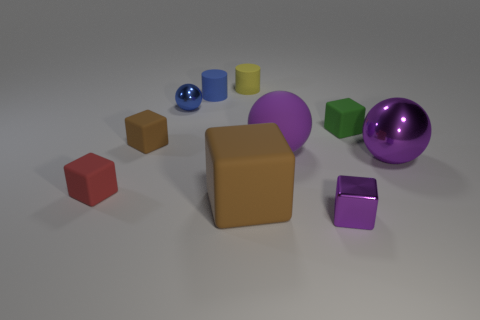There is a brown matte cube on the left side of the big rubber cube; what size is it?
Your answer should be very brief. Small. What number of yellow things are either tiny cylinders or small things?
Keep it short and to the point. 1. There is a small purple object that is the same shape as the small red rubber thing; what is it made of?
Your answer should be compact. Metal. Are there the same number of small green cubes in front of the tiny purple object and large red rubber cylinders?
Your answer should be very brief. Yes. What size is the thing that is both to the left of the large brown block and behind the blue shiny object?
Offer a terse response. Small. Is there anything else that is the same color as the tiny ball?
Give a very brief answer. Yes. There is a thing that is left of the brown rubber cube left of the large brown object; how big is it?
Offer a terse response. Small. There is a matte thing that is on the left side of the yellow cylinder and behind the blue metallic thing; what is its color?
Your answer should be very brief. Blue. How many other things are there of the same size as the yellow matte object?
Offer a very short reply. 6. There is a green thing; is it the same size as the shiny object behind the green matte object?
Offer a terse response. Yes. 